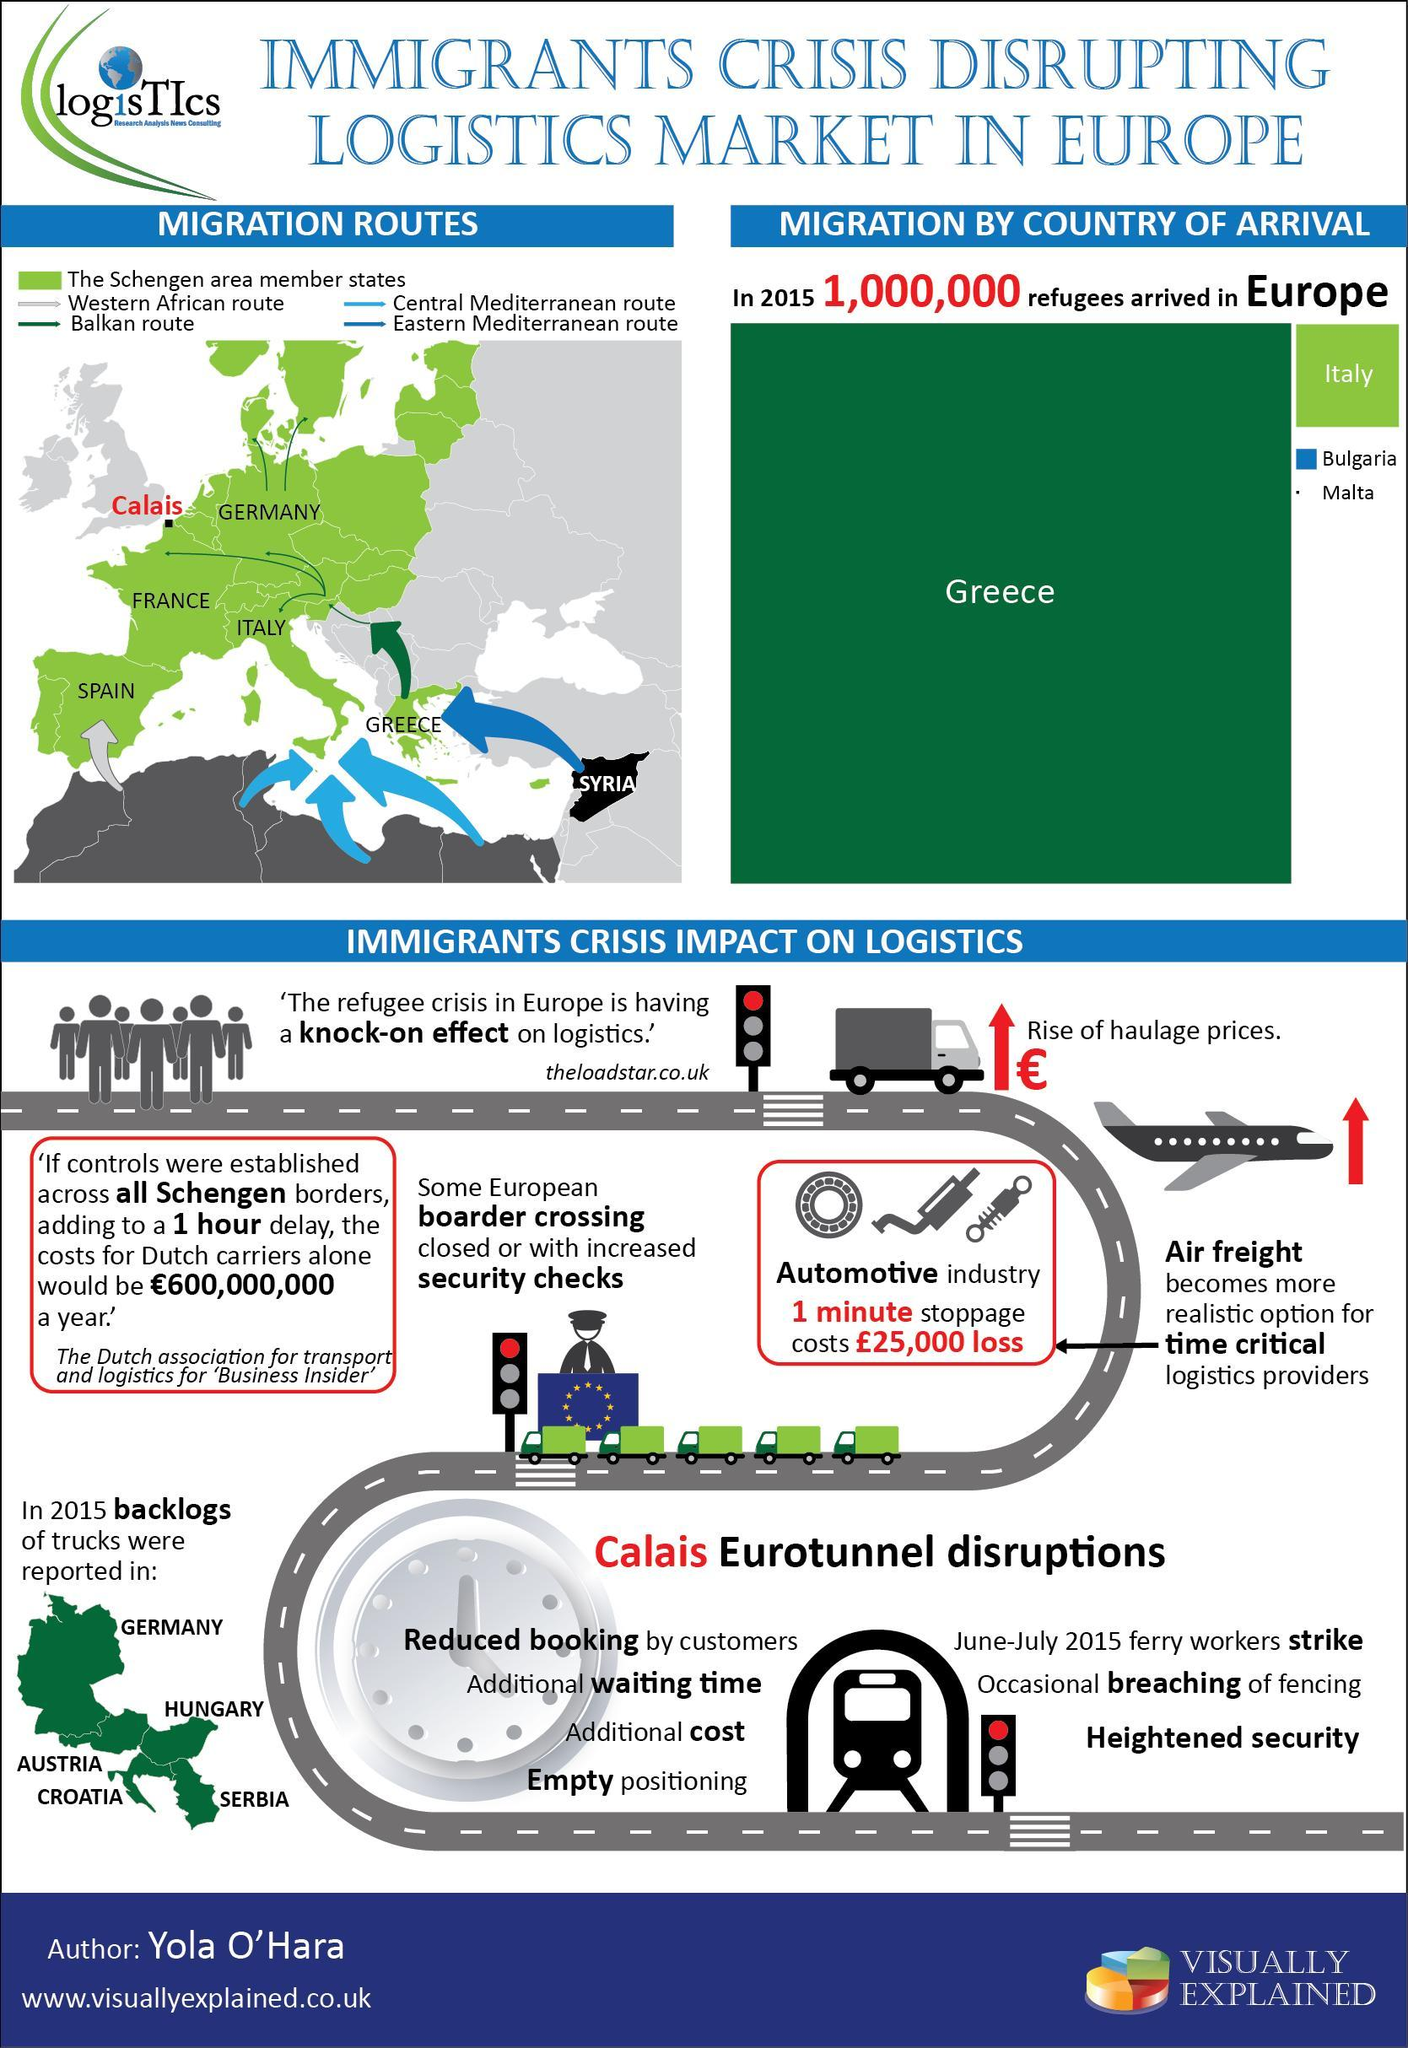In which country of European continent second highest no of immigrants were arrived?
Answer the question with a short phrase. Italy Which is the country shown in Black background color in the map? Syria 